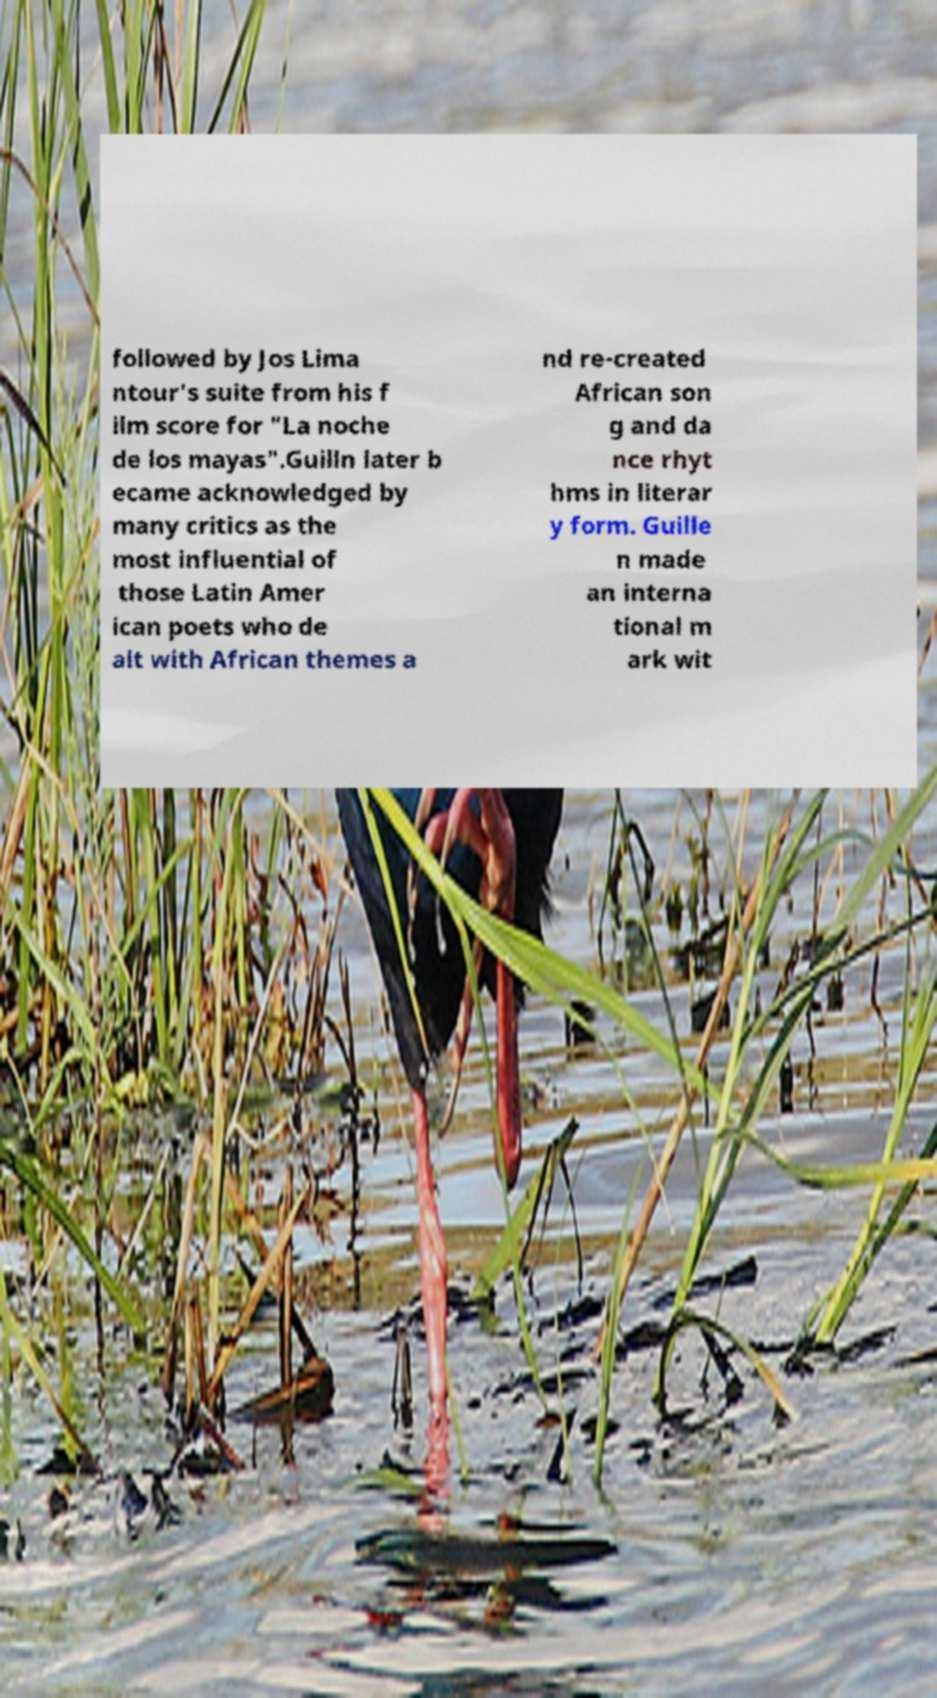Could you extract and type out the text from this image? followed by Jos Lima ntour's suite from his f ilm score for "La noche de los mayas".Guilln later b ecame acknowledged by many critics as the most influential of those Latin Amer ican poets who de alt with African themes a nd re-created African son g and da nce rhyt hms in literar y form. Guille n made an interna tional m ark wit 